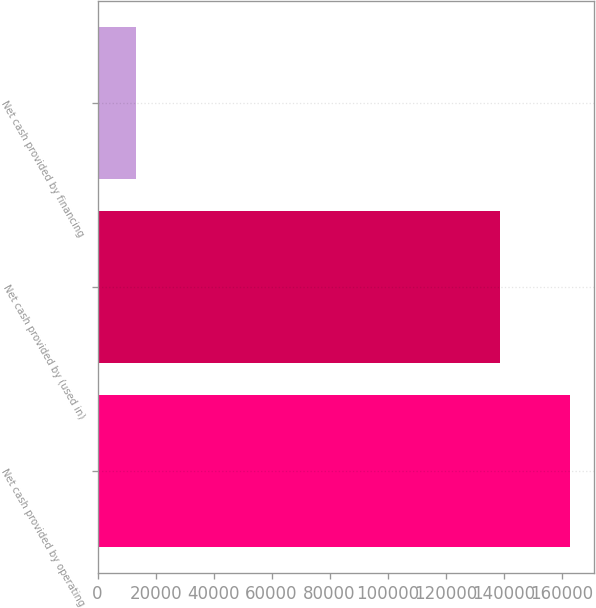<chart> <loc_0><loc_0><loc_500><loc_500><bar_chart><fcel>Net cash provided by operating<fcel>Net cash provided by (used in)<fcel>Net cash provided by financing<nl><fcel>162977<fcel>138718<fcel>13314<nl></chart> 